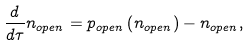<formula> <loc_0><loc_0><loc_500><loc_500>\frac { d } { d \tau } n _ { o p e n } = p _ { o p e n } \left ( n _ { o p e n } \right ) - n _ { o p e n } ,</formula> 